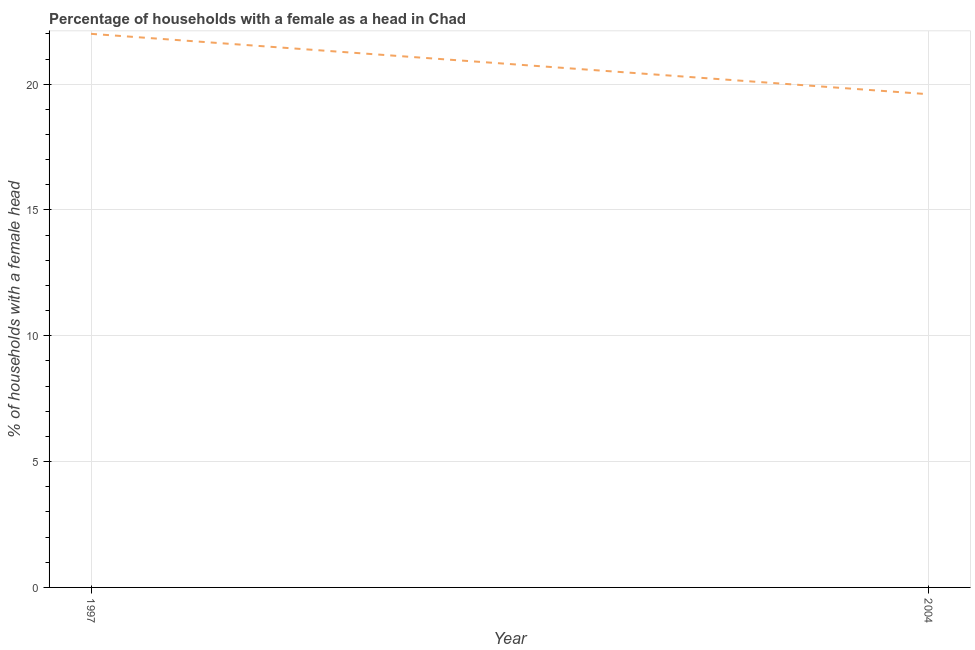Across all years, what is the maximum number of female supervised households?
Make the answer very short. 22. Across all years, what is the minimum number of female supervised households?
Offer a very short reply. 19.6. What is the sum of the number of female supervised households?
Provide a short and direct response. 41.6. What is the difference between the number of female supervised households in 1997 and 2004?
Provide a succinct answer. 2.4. What is the average number of female supervised households per year?
Make the answer very short. 20.8. What is the median number of female supervised households?
Offer a very short reply. 20.8. In how many years, is the number of female supervised households greater than 3 %?
Your answer should be compact. 2. What is the ratio of the number of female supervised households in 1997 to that in 2004?
Keep it short and to the point. 1.12. In how many years, is the number of female supervised households greater than the average number of female supervised households taken over all years?
Your response must be concise. 1. How many lines are there?
Offer a very short reply. 1. What is the difference between two consecutive major ticks on the Y-axis?
Your answer should be very brief. 5. Does the graph contain grids?
Provide a short and direct response. Yes. What is the title of the graph?
Make the answer very short. Percentage of households with a female as a head in Chad. What is the label or title of the X-axis?
Give a very brief answer. Year. What is the label or title of the Y-axis?
Your response must be concise. % of households with a female head. What is the % of households with a female head in 2004?
Keep it short and to the point. 19.6. What is the ratio of the % of households with a female head in 1997 to that in 2004?
Make the answer very short. 1.12. 